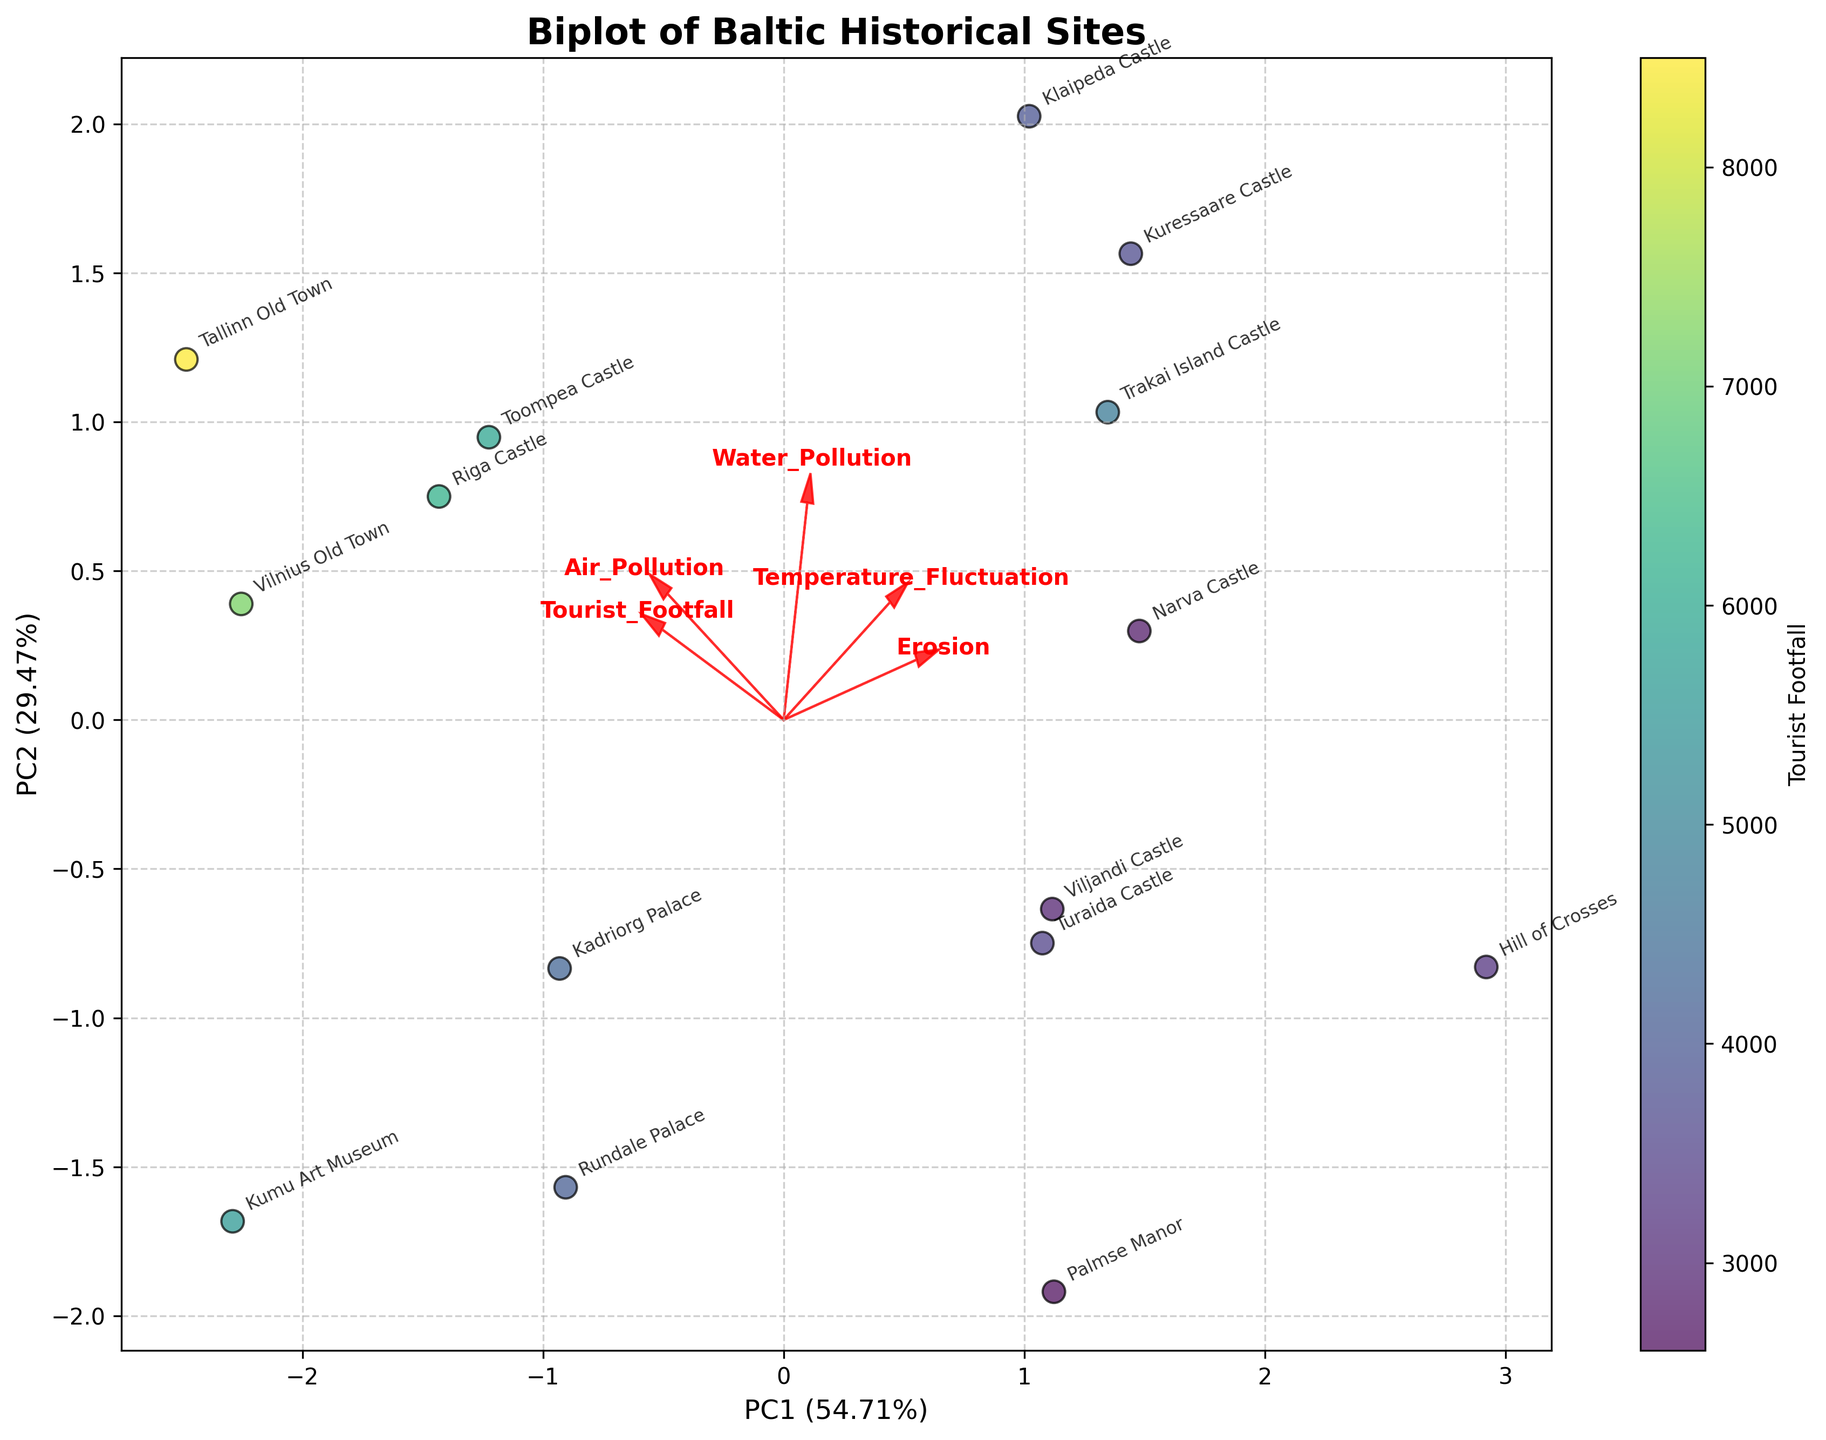What's the title of the plot? The title is located at the top center of the figure.
Answer: Biplot of Baltic Historical Sites How many historical sites are plotted? Each data point represents a historical site. Count the number of data points.
Answer: 15 Which site has the highest tourist footfall? Tourist footfall is represented by the color intensity. The site with the darkest color has the highest footfall.
Answer: Tallinn Old Town What axis explains the most variance in the data? The x-axis (PC1) and y-axis (PC2) have labels showing % variance explanation. The axis with the higher percentage explains the most variance.
Answer: PC1 Which environmental factor vector has the highest contribution to PC2? Find the vector arrow that stretches furthest along the y-axis (PC2).
Answer: Erosion Which site is closest to the Air Pollution vector? The location closest to the direction of the Air Pollution vector arrow is the closest site.
Answer: Toompea Castle Among the listed vectors, which two are most positively correlated? Look at the vectors' directions. Vectors pointing in the same direction have a high positive correlation.
Answer: Water Pollution and Erosion Which site has a moderate temperature fluctuation and low water pollution? Find the site that is located moderately along the Temperature Fluctuation vector and low along the Water Pollution vector.
Answer: Rundale Palace Compare the tourist footfall of Vilnius Old Town and Narva Castle. Which one is higher? Check the color intensity for both Vilnius Old Town and Narva Castle; the site with the darker color has a higher footfall.
Answer: Vilnius Old Town For which environmental factor is Kuressaare Castle the most affected? Look where Kuressaare Castle lies closer towards a vector relative to others.
Answer: Water Pollution 